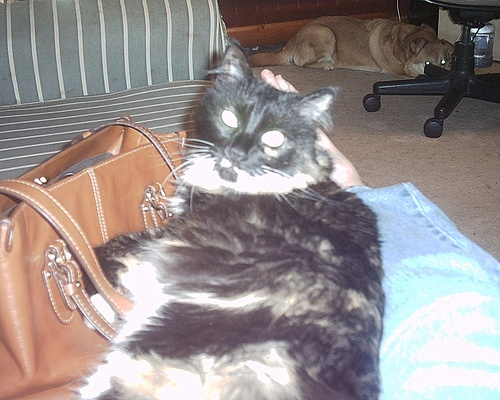Describe the objects in this image and their specific colors. I can see cat in darkgray, gray, and white tones, couch in darkgray, white, gray, and lightblue tones, handbag in darkgray, tan, gray, and lightgray tones, people in darkgray, white, and lightblue tones, and dog in darkgray, gray, maroon, and black tones in this image. 